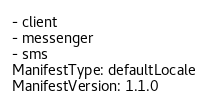<code> <loc_0><loc_0><loc_500><loc_500><_YAML_>- client
- messenger
- sms
ManifestType: defaultLocale
ManifestVersion: 1.1.0
</code> 